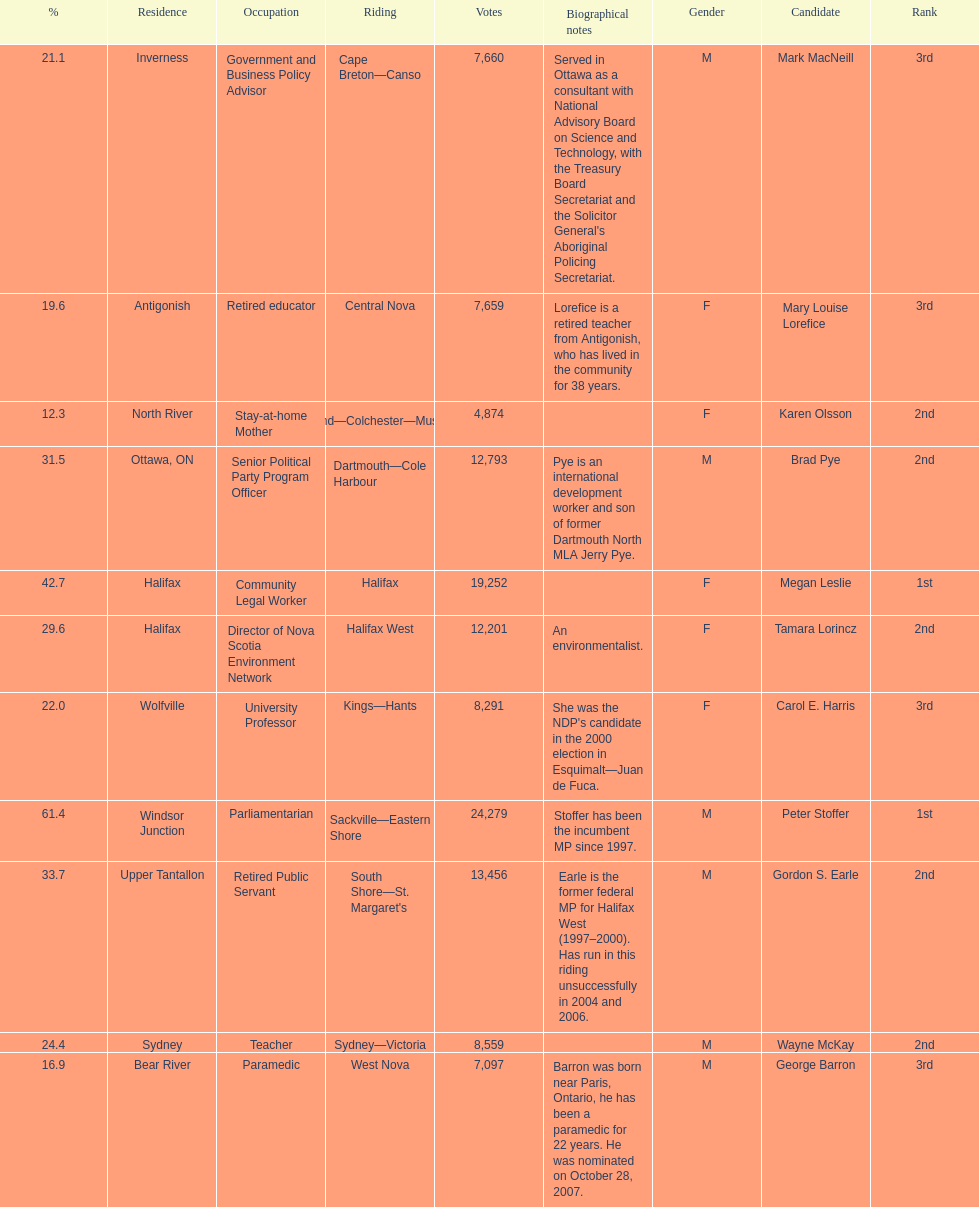What is the total number of candidates? 11. 